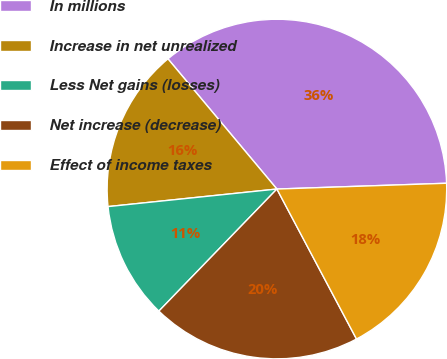Convert chart. <chart><loc_0><loc_0><loc_500><loc_500><pie_chart><fcel>In millions<fcel>Increase in net unrealized<fcel>Less Net gains (losses)<fcel>Net increase (decrease)<fcel>Effect of income taxes<nl><fcel>35.55%<fcel>15.56%<fcel>11.12%<fcel>20.0%<fcel>17.78%<nl></chart> 